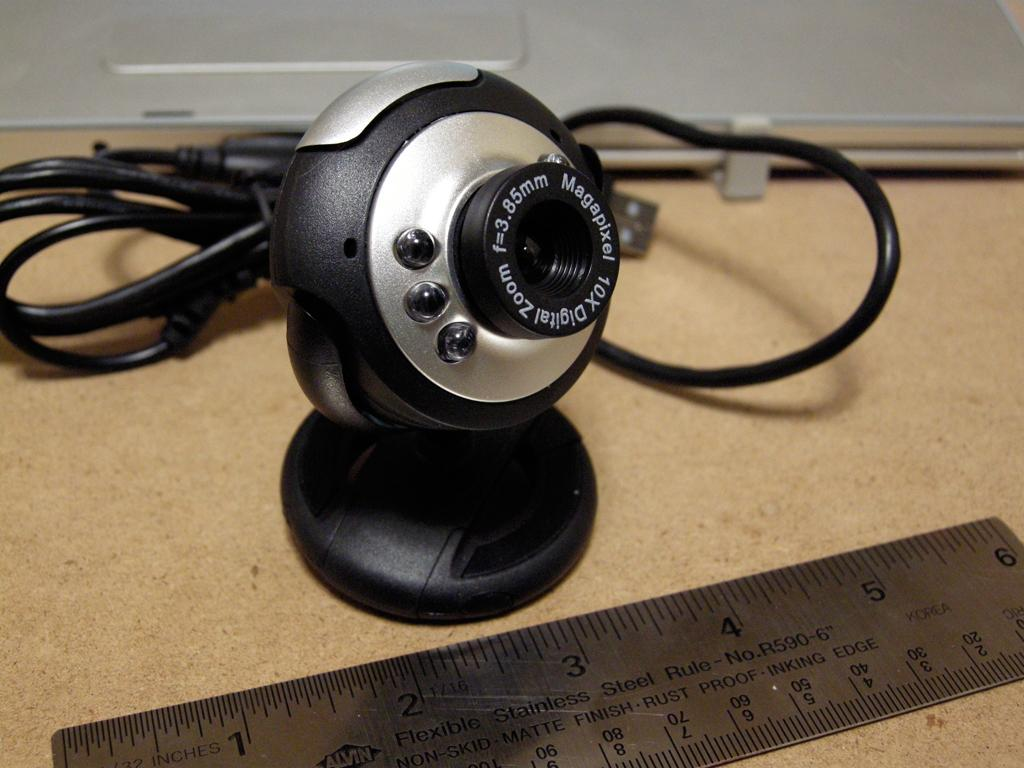<image>
Present a compact description of the photo's key features. A webcam has a 10x digital zoom feature. 